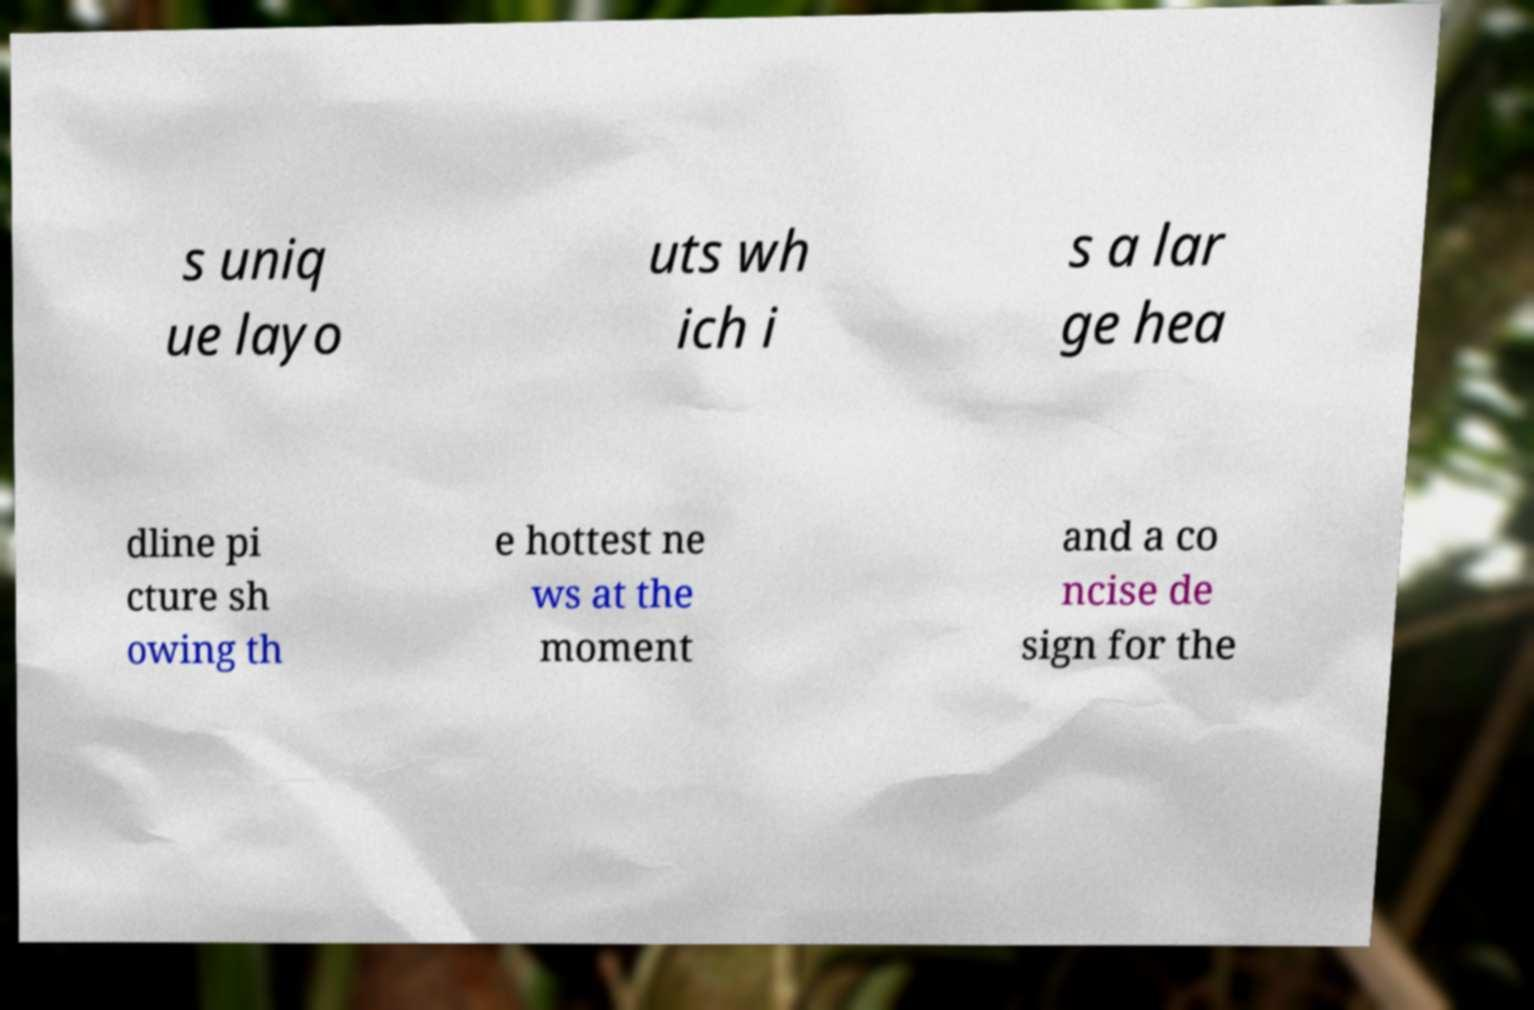I need the written content from this picture converted into text. Can you do that? s uniq ue layo uts wh ich i s a lar ge hea dline pi cture sh owing th e hottest ne ws at the moment and a co ncise de sign for the 